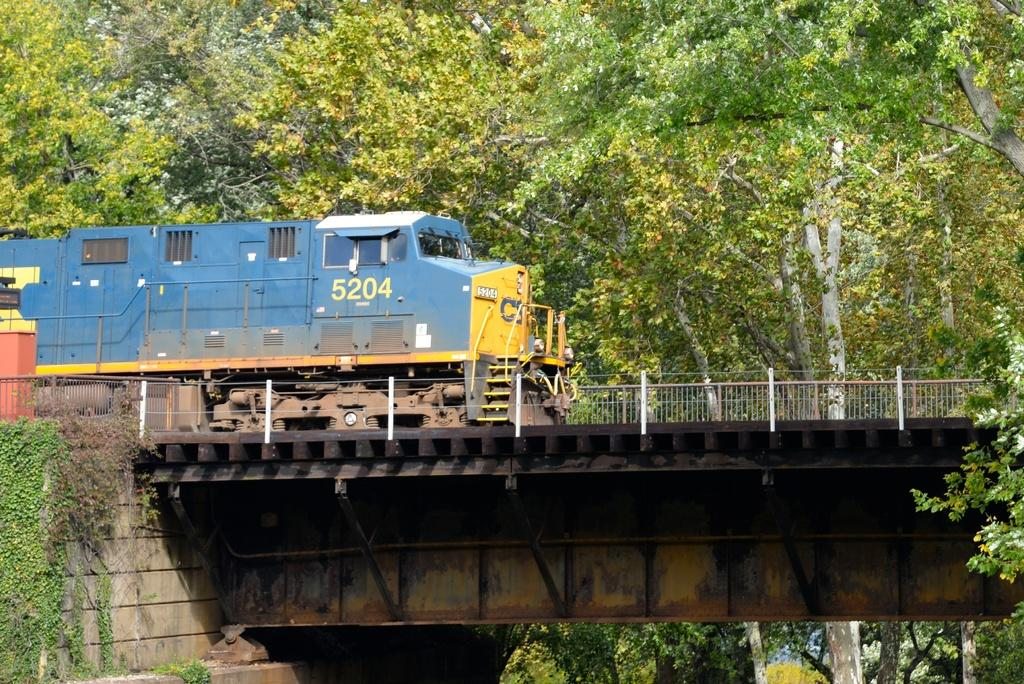Provide a one-sentence caption for the provided image. A blue train numbered 5204 passing over a bridge. 